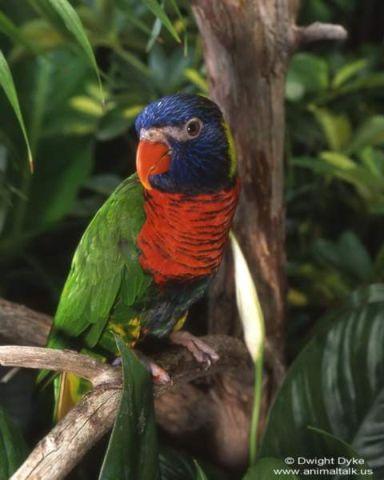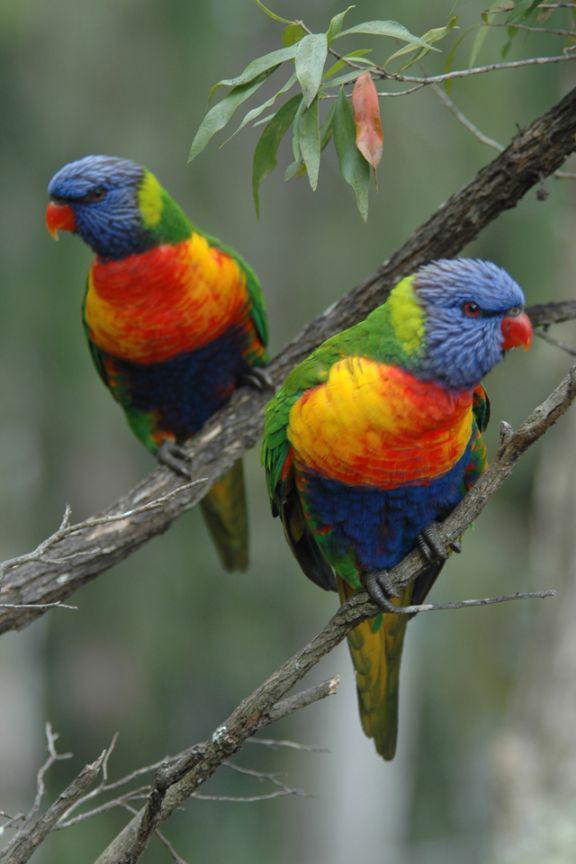The first image is the image on the left, the second image is the image on the right. Evaluate the accuracy of this statement regarding the images: "There are no more than three birds". Is it true? Answer yes or no. Yes. The first image is the image on the left, the second image is the image on the right. Evaluate the accuracy of this statement regarding the images: "The right and left images contain the same number of parrots.". Is it true? Answer yes or no. No. 